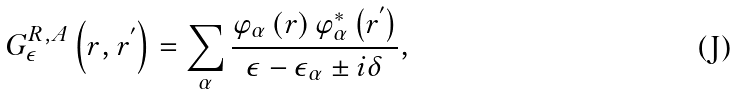Convert formula to latex. <formula><loc_0><loc_0><loc_500><loc_500>G _ { \epsilon } ^ { R , A } \left ( r , r ^ { ^ { \prime } } \right ) = \sum _ { \alpha } \frac { \varphi _ { \alpha } \left ( r \right ) \varphi _ { \alpha } ^ { * } \left ( r ^ { ^ { \prime } } \right ) } { \epsilon - \epsilon _ { \alpha } \pm i \delta } ,</formula> 